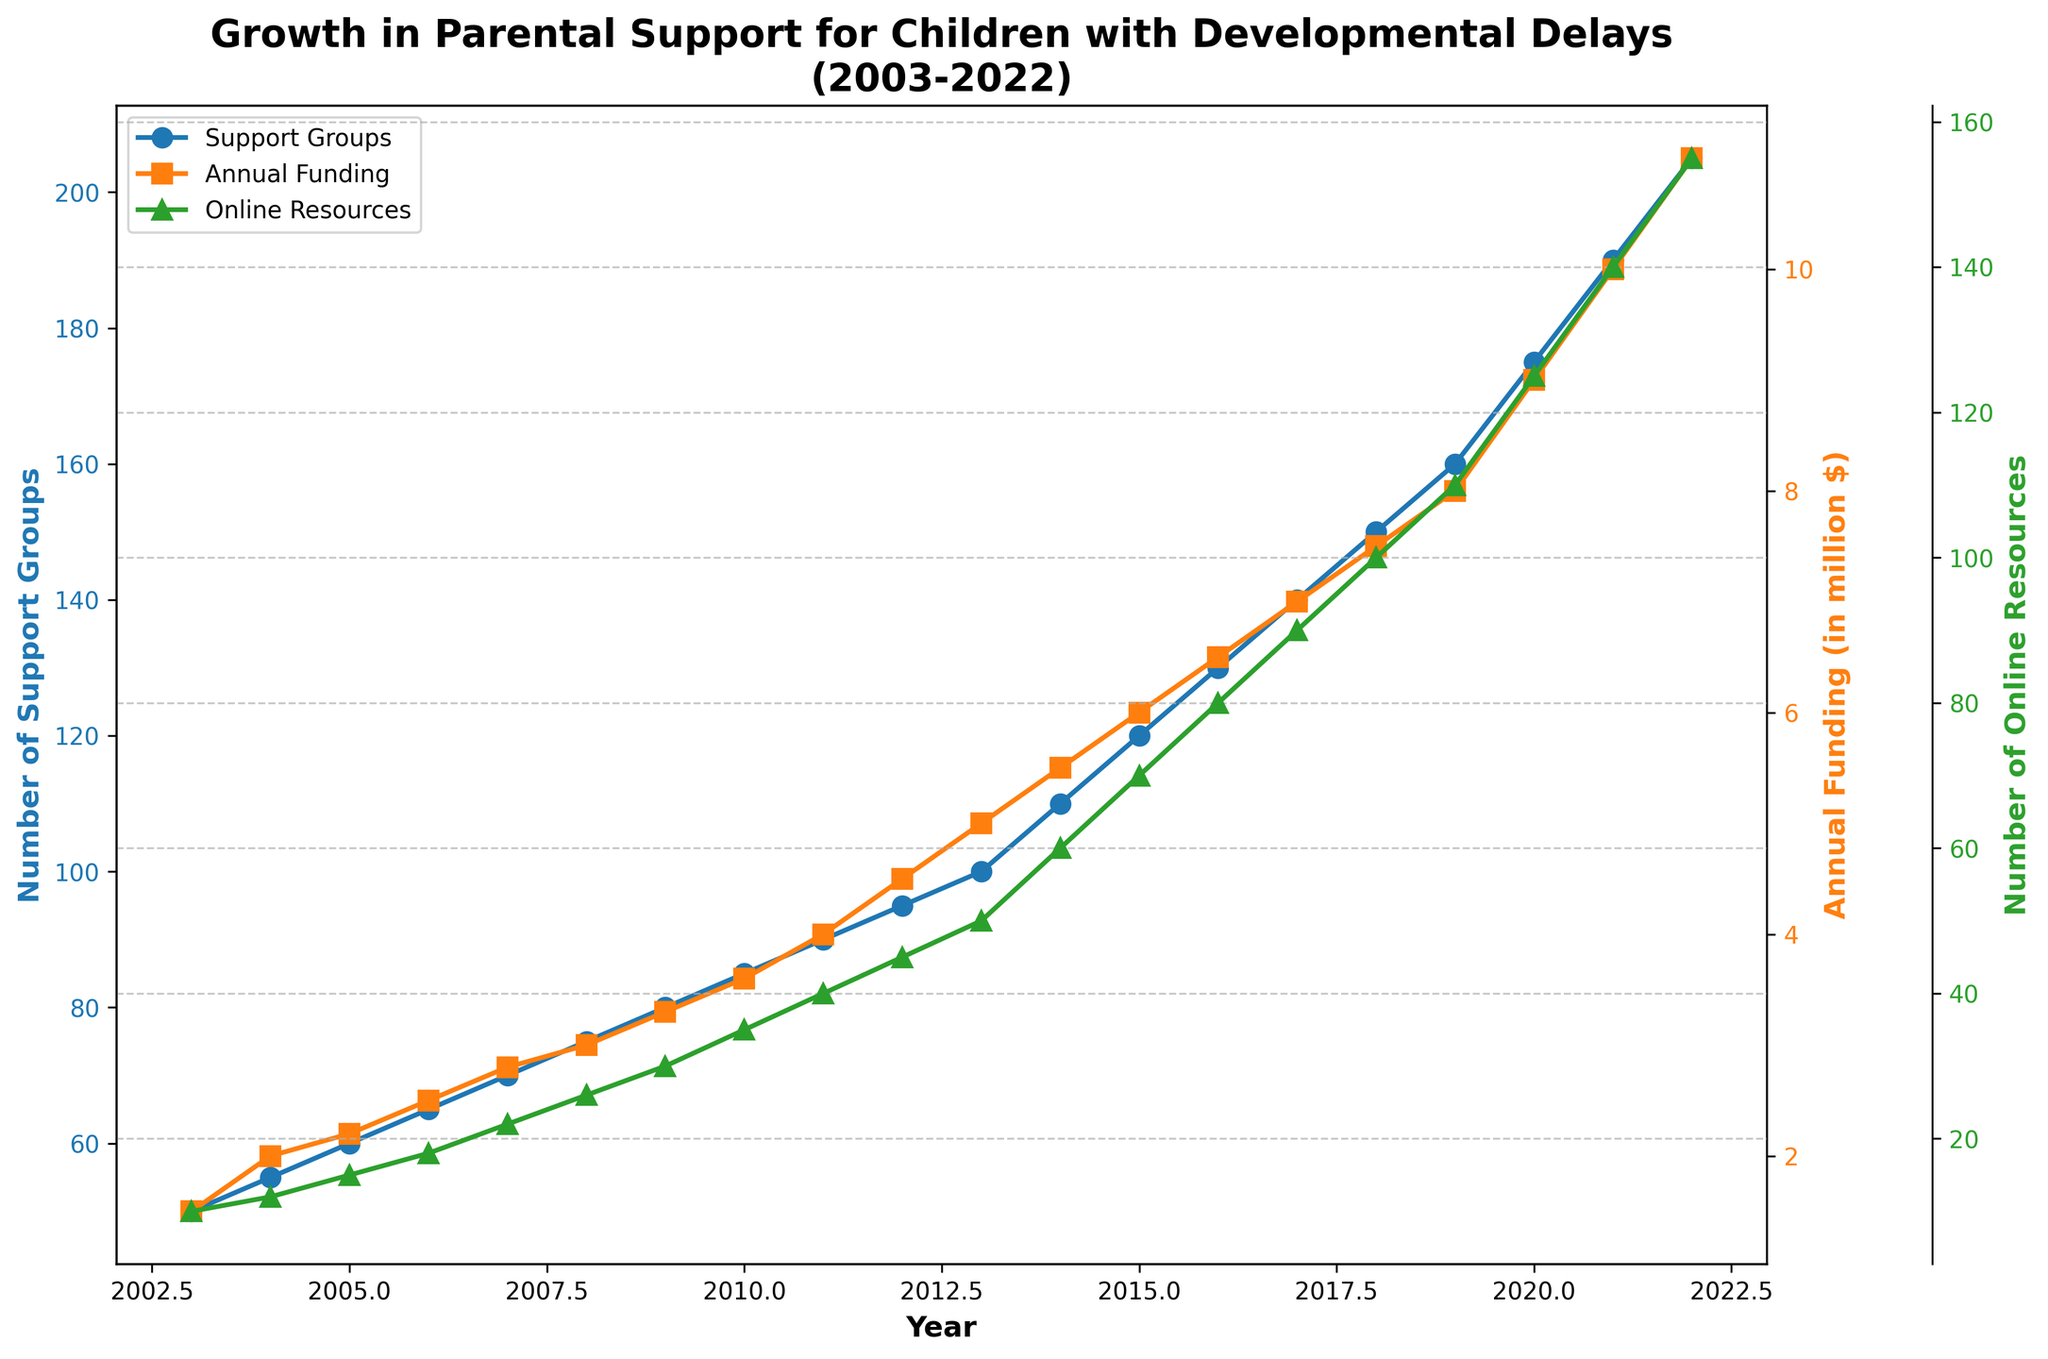what is the title of the figure? The title is present at the top of the figure, indicating what the plot is about.
Answer: Growth in Parental Support for Children with Developmental Delays (2003-2022) what is the color used for plotting the number of support groups? The color used for plotting is seen as blue lines with circular markers for each year's data point.
Answer: Blue how many years of data are shown in the figure? To count the number of years covered, we see that the x-axis starts at 2003 and ends at 2022. This represents a span of 20 years.
Answer: 20 years in which year did the number of support groups first reach 100? To answer this, look at the blue line and find the year corresponding to the point where the marker reaches 100 on the y-axis.
Answer: 2013 comparing 2006 and 2016, which year had more online resources and by how much? Check the green line with triangular markers for both years' values and find the difference. For 2006, it is 18, and for 2016, it is 80. The difference is 62.
Answer: 2016 by 62 what was the annual funding for resources in 2007 and how does it compare to 2020? Looking up the orange line with square markers for these years, 2007 had $2.8 million, and 2020 had $9 million. The funding in 2020 is $9M - $2.8M = $6.2M more than in 2007.
Answer: $6.2 million more what is the general trend seen in the growth of online resources over the period shown? The green line with triangular markers generally increases over time, indicating a continual upward trend in the number of online resources.
Answer: Continuous upward trend how much did the number of support groups increase from 2019 to 2022? To find this, note the values in 2019 and 2022 from the blue line. In 2019 it was 160, and in 2022 it was 205. The increase is 205 - 160 = 45.
Answer: 45 what was the range of annual funding for resources between 2003 and 2022? Identify the minimum and maximum values on the orange line for annual funding. The minimum value is $1.5 million (2003), and the maximum is $11 million (2022). The range is $11M - $1.5M = $9.5M.
Answer: $9.5 million 